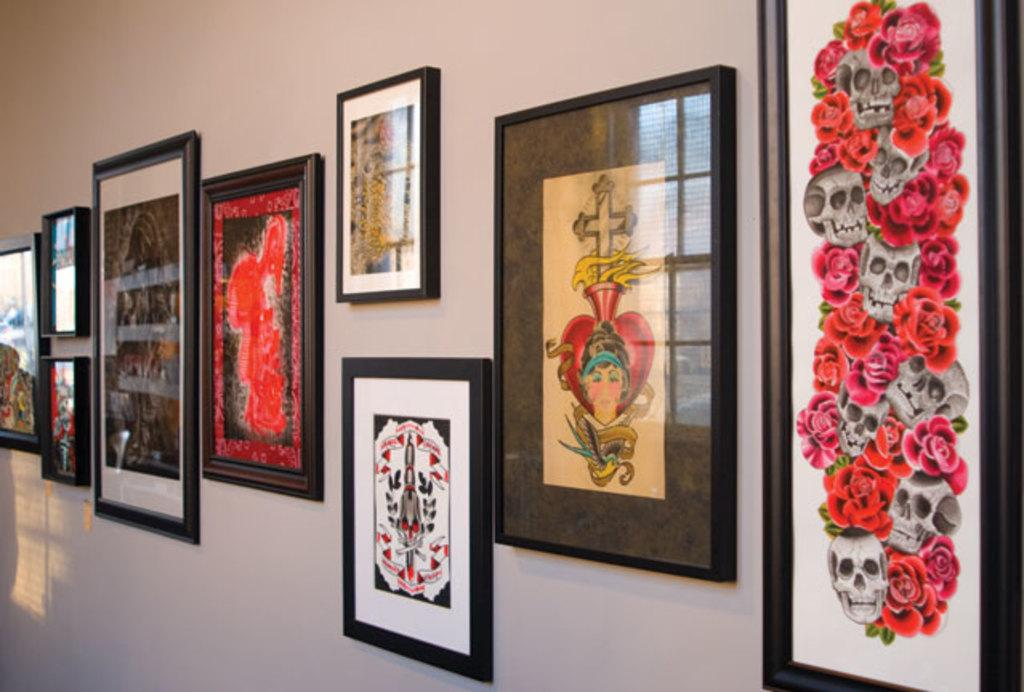What is present on the wall in the image? The image contains frames that are attached to a wall. Can you see a boy playing with a spot in the image? There is no boy or spot present in the image; it only contains frames attached to a wall. Are there any clouds visible in the image? There are no clouds visible in the image, as it only contains frames attached to a wall. 